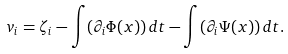<formula> <loc_0><loc_0><loc_500><loc_500>v _ { i } = \zeta _ { i } - \int ( \partial _ { i } \Phi ( x ) ) \, d t - \int ( \partial _ { i } \Psi ( x ) ) \, d t .</formula> 